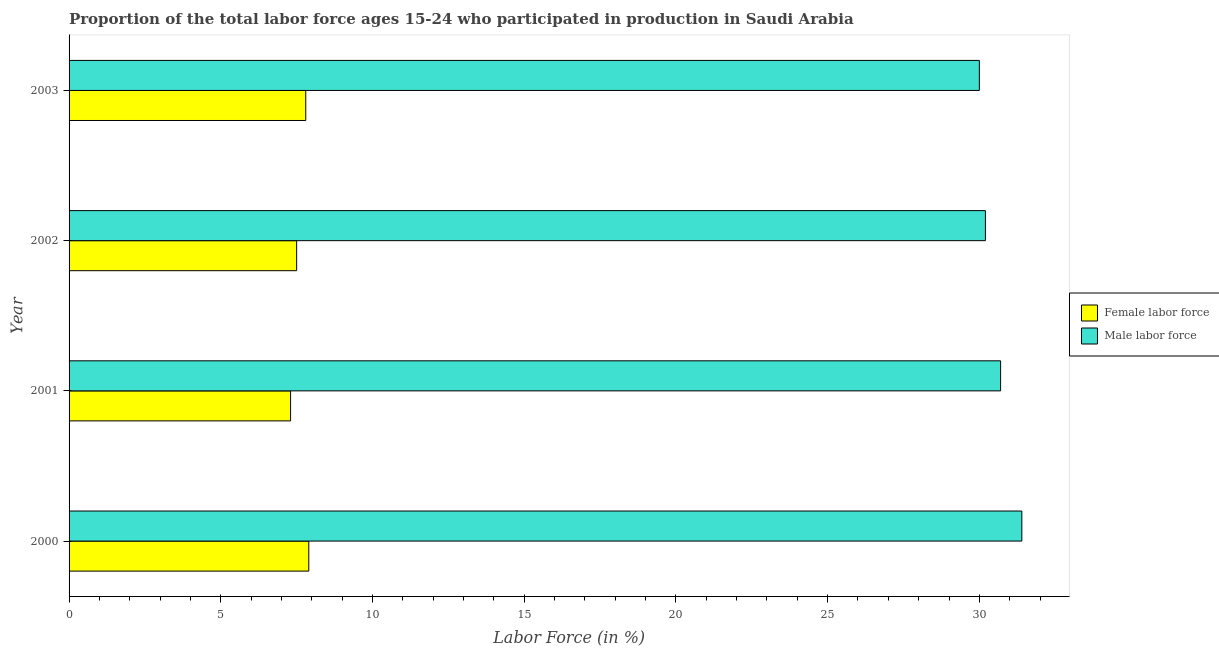How many different coloured bars are there?
Keep it short and to the point. 2. Are the number of bars per tick equal to the number of legend labels?
Offer a terse response. Yes. Are the number of bars on each tick of the Y-axis equal?
Provide a short and direct response. Yes. How many bars are there on the 2nd tick from the bottom?
Give a very brief answer. 2. What is the percentage of female labor force in 2001?
Your response must be concise. 7.3. Across all years, what is the maximum percentage of male labour force?
Offer a terse response. 31.4. Across all years, what is the minimum percentage of female labor force?
Provide a succinct answer. 7.3. What is the total percentage of female labor force in the graph?
Your answer should be very brief. 30.5. What is the difference between the percentage of male labour force in 2000 and that in 2002?
Provide a succinct answer. 1.2. What is the difference between the percentage of female labor force in 2003 and the percentage of male labour force in 2001?
Offer a very short reply. -22.9. What is the average percentage of male labour force per year?
Make the answer very short. 30.57. What is the ratio of the percentage of female labor force in 2000 to that in 2001?
Give a very brief answer. 1.08. Is the percentage of female labor force in 2001 less than that in 2002?
Ensure brevity in your answer.  Yes. Is the difference between the percentage of female labor force in 2000 and 2001 greater than the difference between the percentage of male labour force in 2000 and 2001?
Your response must be concise. No. What is the difference between the highest and the lowest percentage of female labor force?
Offer a terse response. 0.6. Is the sum of the percentage of male labour force in 2000 and 2002 greater than the maximum percentage of female labor force across all years?
Ensure brevity in your answer.  Yes. What does the 2nd bar from the top in 2001 represents?
Your response must be concise. Female labor force. What does the 1st bar from the bottom in 2003 represents?
Offer a terse response. Female labor force. How many bars are there?
Make the answer very short. 8. Are all the bars in the graph horizontal?
Provide a succinct answer. Yes. How many years are there in the graph?
Give a very brief answer. 4. Does the graph contain any zero values?
Your answer should be very brief. No. Does the graph contain grids?
Ensure brevity in your answer.  No. Where does the legend appear in the graph?
Make the answer very short. Center right. How many legend labels are there?
Your answer should be compact. 2. What is the title of the graph?
Offer a terse response. Proportion of the total labor force ages 15-24 who participated in production in Saudi Arabia. Does "Gasoline" appear as one of the legend labels in the graph?
Ensure brevity in your answer.  No. What is the label or title of the X-axis?
Your answer should be very brief. Labor Force (in %). What is the label or title of the Y-axis?
Make the answer very short. Year. What is the Labor Force (in %) of Female labor force in 2000?
Your response must be concise. 7.9. What is the Labor Force (in %) in Male labor force in 2000?
Your answer should be very brief. 31.4. What is the Labor Force (in %) of Female labor force in 2001?
Make the answer very short. 7.3. What is the Labor Force (in %) in Male labor force in 2001?
Ensure brevity in your answer.  30.7. What is the Labor Force (in %) in Male labor force in 2002?
Give a very brief answer. 30.2. What is the Labor Force (in %) in Female labor force in 2003?
Provide a succinct answer. 7.8. Across all years, what is the maximum Labor Force (in %) of Female labor force?
Offer a terse response. 7.9. Across all years, what is the maximum Labor Force (in %) of Male labor force?
Ensure brevity in your answer.  31.4. Across all years, what is the minimum Labor Force (in %) of Female labor force?
Offer a very short reply. 7.3. Across all years, what is the minimum Labor Force (in %) of Male labor force?
Provide a succinct answer. 30. What is the total Labor Force (in %) of Female labor force in the graph?
Provide a succinct answer. 30.5. What is the total Labor Force (in %) in Male labor force in the graph?
Provide a short and direct response. 122.3. What is the difference between the Labor Force (in %) in Male labor force in 2000 and that in 2002?
Ensure brevity in your answer.  1.2. What is the difference between the Labor Force (in %) in Male labor force in 2000 and that in 2003?
Your response must be concise. 1.4. What is the difference between the Labor Force (in %) of Female labor force in 2001 and that in 2003?
Your response must be concise. -0.5. What is the difference between the Labor Force (in %) in Male labor force in 2002 and that in 2003?
Give a very brief answer. 0.2. What is the difference between the Labor Force (in %) of Female labor force in 2000 and the Labor Force (in %) of Male labor force in 2001?
Your answer should be very brief. -22.8. What is the difference between the Labor Force (in %) of Female labor force in 2000 and the Labor Force (in %) of Male labor force in 2002?
Provide a short and direct response. -22.3. What is the difference between the Labor Force (in %) in Female labor force in 2000 and the Labor Force (in %) in Male labor force in 2003?
Your answer should be compact. -22.1. What is the difference between the Labor Force (in %) of Female labor force in 2001 and the Labor Force (in %) of Male labor force in 2002?
Offer a terse response. -22.9. What is the difference between the Labor Force (in %) of Female labor force in 2001 and the Labor Force (in %) of Male labor force in 2003?
Your answer should be compact. -22.7. What is the difference between the Labor Force (in %) of Female labor force in 2002 and the Labor Force (in %) of Male labor force in 2003?
Provide a short and direct response. -22.5. What is the average Labor Force (in %) of Female labor force per year?
Ensure brevity in your answer.  7.62. What is the average Labor Force (in %) of Male labor force per year?
Ensure brevity in your answer.  30.57. In the year 2000, what is the difference between the Labor Force (in %) of Female labor force and Labor Force (in %) of Male labor force?
Give a very brief answer. -23.5. In the year 2001, what is the difference between the Labor Force (in %) of Female labor force and Labor Force (in %) of Male labor force?
Provide a short and direct response. -23.4. In the year 2002, what is the difference between the Labor Force (in %) in Female labor force and Labor Force (in %) in Male labor force?
Your response must be concise. -22.7. In the year 2003, what is the difference between the Labor Force (in %) of Female labor force and Labor Force (in %) of Male labor force?
Your answer should be very brief. -22.2. What is the ratio of the Labor Force (in %) of Female labor force in 2000 to that in 2001?
Make the answer very short. 1.08. What is the ratio of the Labor Force (in %) in Male labor force in 2000 to that in 2001?
Your answer should be very brief. 1.02. What is the ratio of the Labor Force (in %) of Female labor force in 2000 to that in 2002?
Offer a terse response. 1.05. What is the ratio of the Labor Force (in %) of Male labor force in 2000 to that in 2002?
Your response must be concise. 1.04. What is the ratio of the Labor Force (in %) in Female labor force in 2000 to that in 2003?
Give a very brief answer. 1.01. What is the ratio of the Labor Force (in %) of Male labor force in 2000 to that in 2003?
Your answer should be very brief. 1.05. What is the ratio of the Labor Force (in %) in Female labor force in 2001 to that in 2002?
Offer a terse response. 0.97. What is the ratio of the Labor Force (in %) in Male labor force in 2001 to that in 2002?
Your response must be concise. 1.02. What is the ratio of the Labor Force (in %) of Female labor force in 2001 to that in 2003?
Offer a very short reply. 0.94. What is the ratio of the Labor Force (in %) of Male labor force in 2001 to that in 2003?
Your answer should be compact. 1.02. What is the ratio of the Labor Force (in %) in Female labor force in 2002 to that in 2003?
Give a very brief answer. 0.96. What is the ratio of the Labor Force (in %) of Male labor force in 2002 to that in 2003?
Provide a short and direct response. 1.01. What is the difference between the highest and the second highest Labor Force (in %) in Female labor force?
Your answer should be very brief. 0.1. What is the difference between the highest and the lowest Labor Force (in %) of Female labor force?
Your response must be concise. 0.6. What is the difference between the highest and the lowest Labor Force (in %) of Male labor force?
Your answer should be compact. 1.4. 